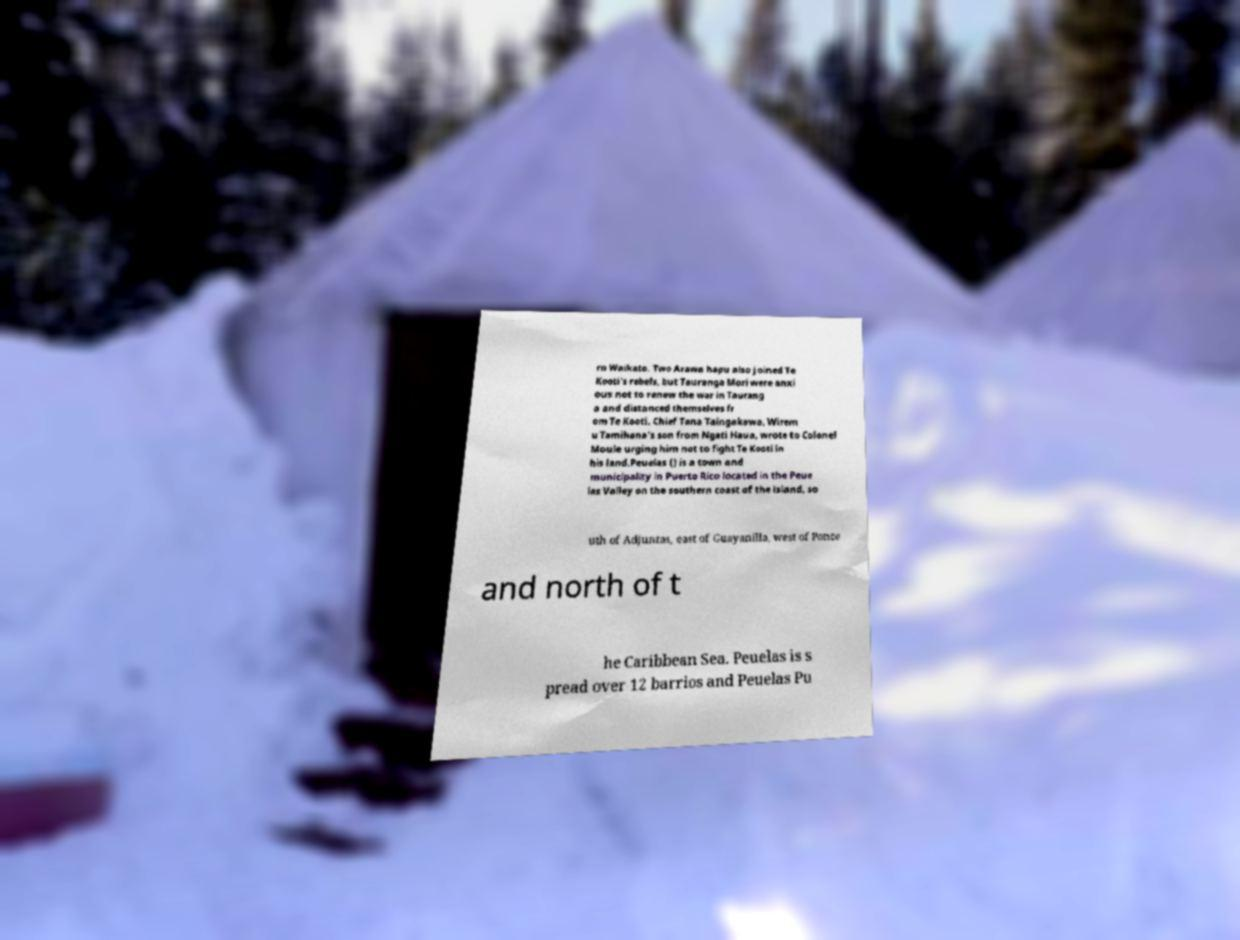There's text embedded in this image that I need extracted. Can you transcribe it verbatim? rn Waikato. Two Arawa hapu also joined Te Kooti's rebels, but Tauranga Mori were anxi ous not to renew the war in Taurang a and distanced themselves fr om Te Kooti. Chief Tana Taingakawa, Wirem u Tamihana's son from Ngati Haua, wrote to Colonel Moule urging him not to fight Te Kooti in his land.Peuelas () is a town and municipality in Puerto Rico located in the Peue las Valley on the southern coast of the island, so uth of Adjuntas, east of Guayanilla, west of Ponce and north of t he Caribbean Sea. Peuelas is s pread over 12 barrios and Peuelas Pu 